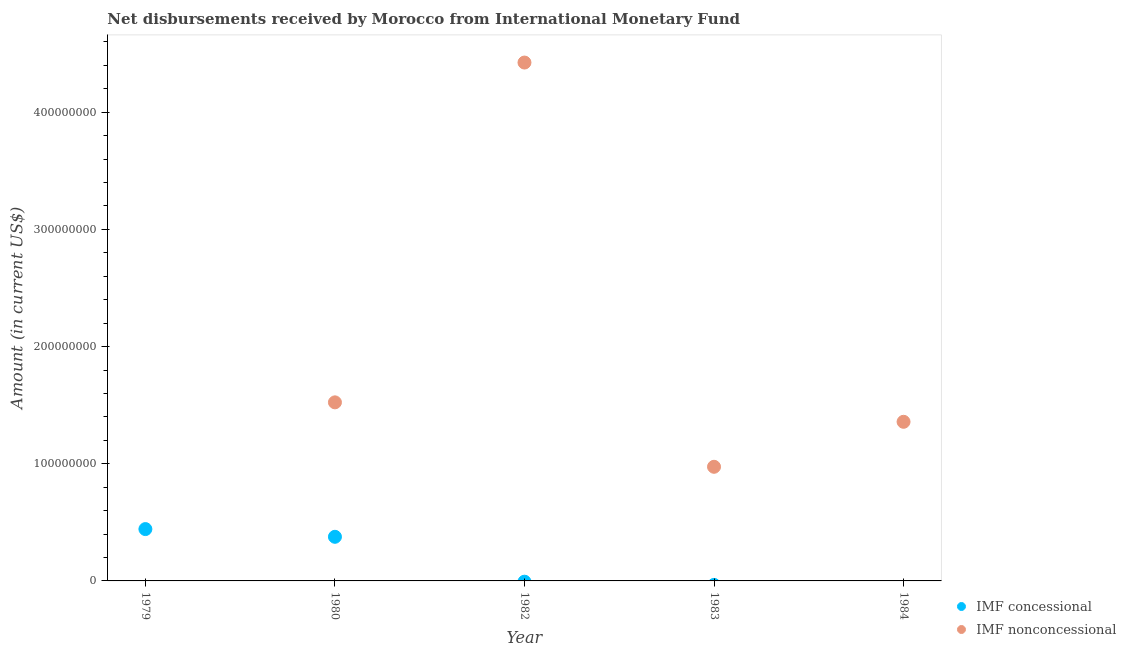What is the net non concessional disbursements from imf in 1980?
Offer a very short reply. 1.52e+08. Across all years, what is the maximum net non concessional disbursements from imf?
Offer a very short reply. 4.42e+08. What is the total net non concessional disbursements from imf in the graph?
Make the answer very short. 8.28e+08. What is the difference between the net non concessional disbursements from imf in 1980 and that in 1984?
Your response must be concise. 1.66e+07. What is the difference between the net non concessional disbursements from imf in 1982 and the net concessional disbursements from imf in 1979?
Offer a very short reply. 3.98e+08. What is the average net non concessional disbursements from imf per year?
Ensure brevity in your answer.  1.66e+08. In the year 1980, what is the difference between the net concessional disbursements from imf and net non concessional disbursements from imf?
Give a very brief answer. -1.15e+08. In how many years, is the net concessional disbursements from imf greater than 420000000 US$?
Provide a short and direct response. 0. What is the ratio of the net non concessional disbursements from imf in 1980 to that in 1983?
Make the answer very short. 1.56. What is the difference between the highest and the second highest net non concessional disbursements from imf?
Make the answer very short. 2.90e+08. What is the difference between the highest and the lowest net concessional disbursements from imf?
Make the answer very short. 4.42e+07. Is the sum of the net non concessional disbursements from imf in 1980 and 1982 greater than the maximum net concessional disbursements from imf across all years?
Give a very brief answer. Yes. Is the net non concessional disbursements from imf strictly greater than the net concessional disbursements from imf over the years?
Give a very brief answer. No. How many dotlines are there?
Your response must be concise. 2. What is the difference between two consecutive major ticks on the Y-axis?
Ensure brevity in your answer.  1.00e+08. Are the values on the major ticks of Y-axis written in scientific E-notation?
Ensure brevity in your answer.  No. What is the title of the graph?
Your answer should be compact. Net disbursements received by Morocco from International Monetary Fund. Does "current US$" appear as one of the legend labels in the graph?
Provide a short and direct response. No. What is the label or title of the X-axis?
Keep it short and to the point. Year. What is the label or title of the Y-axis?
Ensure brevity in your answer.  Amount (in current US$). What is the Amount (in current US$) in IMF concessional in 1979?
Your response must be concise. 4.42e+07. What is the Amount (in current US$) in IMF concessional in 1980?
Provide a succinct answer. 3.77e+07. What is the Amount (in current US$) in IMF nonconcessional in 1980?
Give a very brief answer. 1.52e+08. What is the Amount (in current US$) in IMF concessional in 1982?
Your response must be concise. 0. What is the Amount (in current US$) in IMF nonconcessional in 1982?
Your response must be concise. 4.42e+08. What is the Amount (in current US$) of IMF nonconcessional in 1983?
Your response must be concise. 9.74e+07. What is the Amount (in current US$) of IMF concessional in 1984?
Provide a succinct answer. 0. What is the Amount (in current US$) of IMF nonconcessional in 1984?
Make the answer very short. 1.36e+08. Across all years, what is the maximum Amount (in current US$) in IMF concessional?
Make the answer very short. 4.42e+07. Across all years, what is the maximum Amount (in current US$) in IMF nonconcessional?
Give a very brief answer. 4.42e+08. Across all years, what is the minimum Amount (in current US$) of IMF nonconcessional?
Your answer should be very brief. 0. What is the total Amount (in current US$) in IMF concessional in the graph?
Your response must be concise. 8.19e+07. What is the total Amount (in current US$) in IMF nonconcessional in the graph?
Ensure brevity in your answer.  8.28e+08. What is the difference between the Amount (in current US$) in IMF concessional in 1979 and that in 1980?
Your answer should be compact. 6.59e+06. What is the difference between the Amount (in current US$) of IMF nonconcessional in 1980 and that in 1982?
Offer a very short reply. -2.90e+08. What is the difference between the Amount (in current US$) in IMF nonconcessional in 1980 and that in 1983?
Give a very brief answer. 5.50e+07. What is the difference between the Amount (in current US$) of IMF nonconcessional in 1980 and that in 1984?
Offer a very short reply. 1.66e+07. What is the difference between the Amount (in current US$) of IMF nonconcessional in 1982 and that in 1983?
Make the answer very short. 3.45e+08. What is the difference between the Amount (in current US$) in IMF nonconcessional in 1982 and that in 1984?
Keep it short and to the point. 3.07e+08. What is the difference between the Amount (in current US$) in IMF nonconcessional in 1983 and that in 1984?
Ensure brevity in your answer.  -3.84e+07. What is the difference between the Amount (in current US$) in IMF concessional in 1979 and the Amount (in current US$) in IMF nonconcessional in 1980?
Make the answer very short. -1.08e+08. What is the difference between the Amount (in current US$) of IMF concessional in 1979 and the Amount (in current US$) of IMF nonconcessional in 1982?
Offer a terse response. -3.98e+08. What is the difference between the Amount (in current US$) of IMF concessional in 1979 and the Amount (in current US$) of IMF nonconcessional in 1983?
Provide a short and direct response. -5.32e+07. What is the difference between the Amount (in current US$) in IMF concessional in 1979 and the Amount (in current US$) in IMF nonconcessional in 1984?
Keep it short and to the point. -9.16e+07. What is the difference between the Amount (in current US$) in IMF concessional in 1980 and the Amount (in current US$) in IMF nonconcessional in 1982?
Provide a short and direct response. -4.05e+08. What is the difference between the Amount (in current US$) in IMF concessional in 1980 and the Amount (in current US$) in IMF nonconcessional in 1983?
Provide a short and direct response. -5.97e+07. What is the difference between the Amount (in current US$) in IMF concessional in 1980 and the Amount (in current US$) in IMF nonconcessional in 1984?
Ensure brevity in your answer.  -9.81e+07. What is the average Amount (in current US$) of IMF concessional per year?
Your answer should be compact. 1.64e+07. What is the average Amount (in current US$) in IMF nonconcessional per year?
Ensure brevity in your answer.  1.66e+08. In the year 1980, what is the difference between the Amount (in current US$) of IMF concessional and Amount (in current US$) of IMF nonconcessional?
Your response must be concise. -1.15e+08. What is the ratio of the Amount (in current US$) of IMF concessional in 1979 to that in 1980?
Your answer should be compact. 1.17. What is the ratio of the Amount (in current US$) in IMF nonconcessional in 1980 to that in 1982?
Ensure brevity in your answer.  0.34. What is the ratio of the Amount (in current US$) in IMF nonconcessional in 1980 to that in 1983?
Your answer should be compact. 1.56. What is the ratio of the Amount (in current US$) in IMF nonconcessional in 1980 to that in 1984?
Offer a terse response. 1.12. What is the ratio of the Amount (in current US$) of IMF nonconcessional in 1982 to that in 1983?
Provide a succinct answer. 4.54. What is the ratio of the Amount (in current US$) in IMF nonconcessional in 1982 to that in 1984?
Provide a short and direct response. 3.26. What is the ratio of the Amount (in current US$) in IMF nonconcessional in 1983 to that in 1984?
Offer a very short reply. 0.72. What is the difference between the highest and the second highest Amount (in current US$) in IMF nonconcessional?
Your answer should be very brief. 2.90e+08. What is the difference between the highest and the lowest Amount (in current US$) of IMF concessional?
Give a very brief answer. 4.42e+07. What is the difference between the highest and the lowest Amount (in current US$) in IMF nonconcessional?
Offer a very short reply. 4.42e+08. 